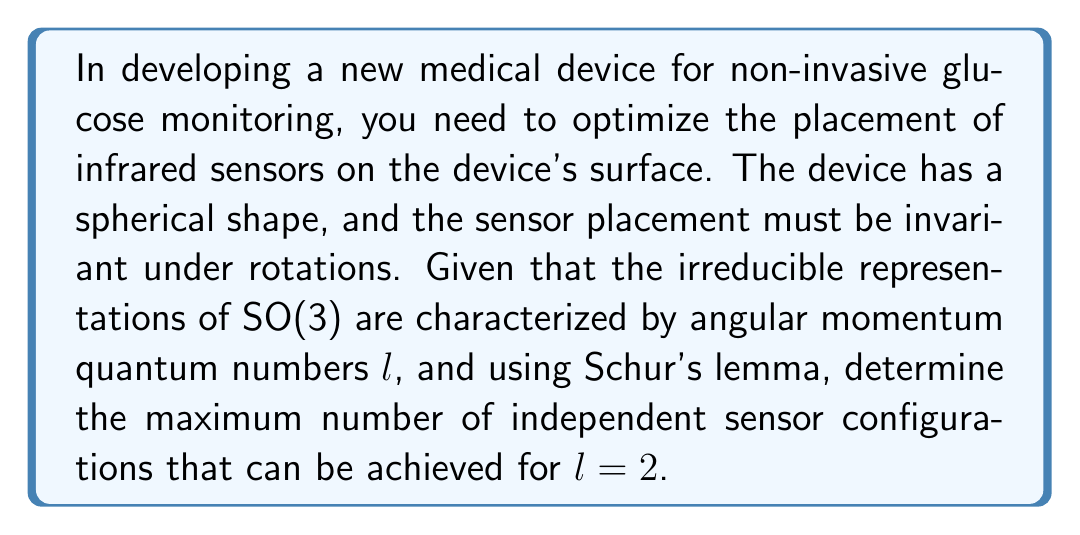What is the answer to this math problem? 1) First, recall Schur's lemma: Any linear map that commutes with all elements of an irreducible representation is a scalar multiple of the identity.

2) In this case, we're dealing with the group SO(3) of rotations in 3D space. The irreducible representations of SO(3) are labeled by the angular momentum quantum number $l$.

3) For $l = 2$, we're working with the 5-dimensional irreducible representation of SO(3). This corresponds to the spherical harmonics $Y_{2m}$ with $m = -2, -1, 0, 1, 2$.

4) The sensor configuration must be invariant under rotations, which means it must commute with all elements of the SO(3) representation.

5) By Schur's lemma, any such invariant configuration must be a scalar multiple of the identity matrix in this representation.

6) The identity matrix in a 5-dimensional space has 5 independent components along its diagonal.

7) Therefore, there can be at most 5 independent sensor configurations that are invariant under rotations for $l = 2$.

8) Physically, these 5 configurations correspond to the 5 independent quadrupole moments that can be measured on the surface of a sphere.
Answer: 5 